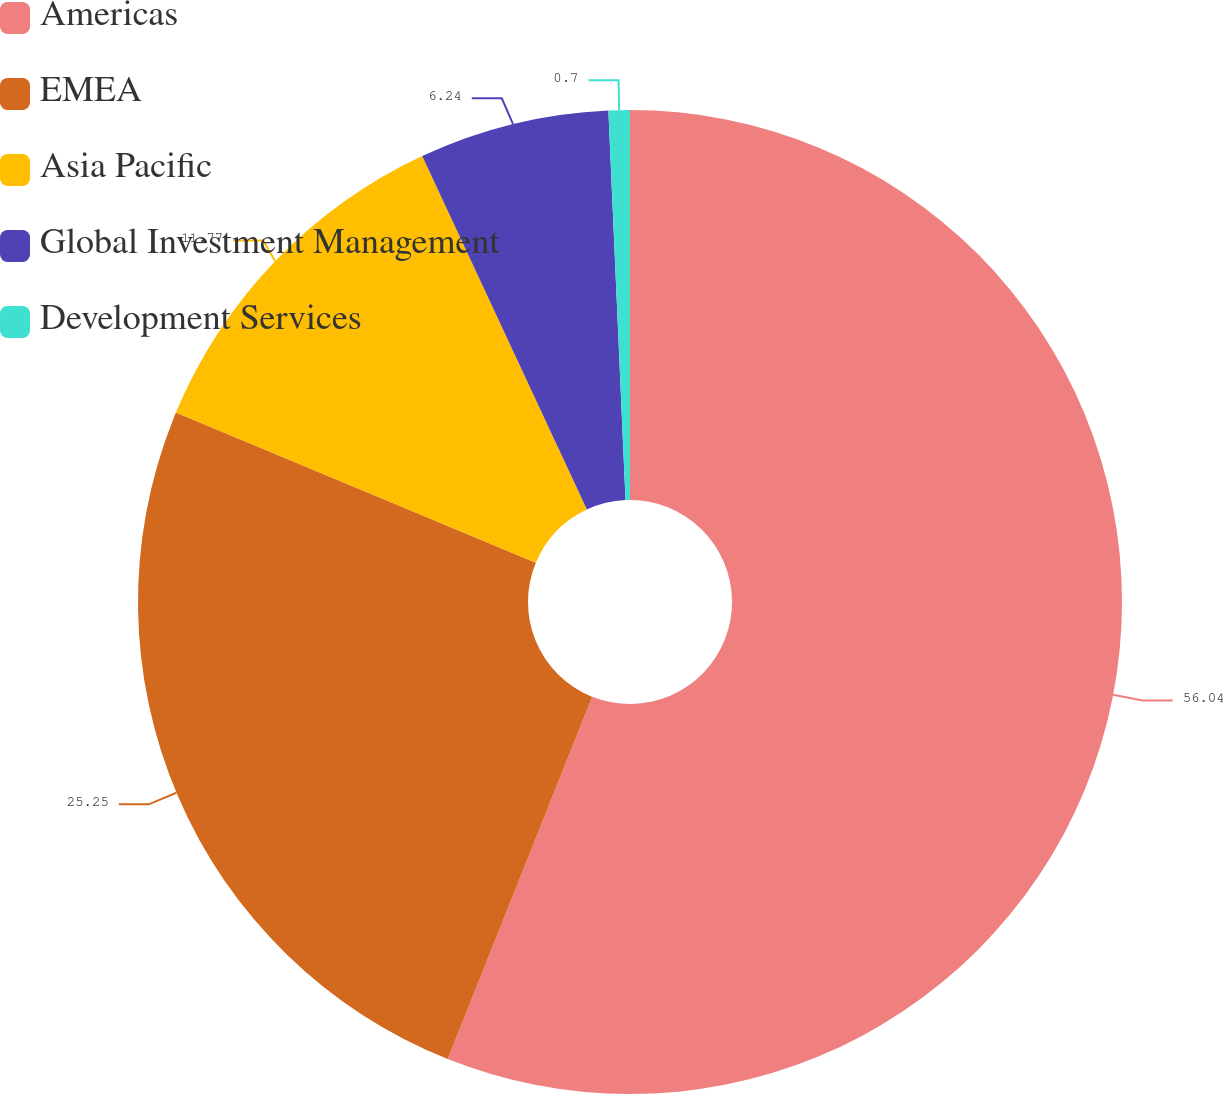Convert chart to OTSL. <chart><loc_0><loc_0><loc_500><loc_500><pie_chart><fcel>Americas<fcel>EMEA<fcel>Asia Pacific<fcel>Global Investment Management<fcel>Development Services<nl><fcel>56.04%<fcel>25.25%<fcel>11.77%<fcel>6.24%<fcel>0.7%<nl></chart> 